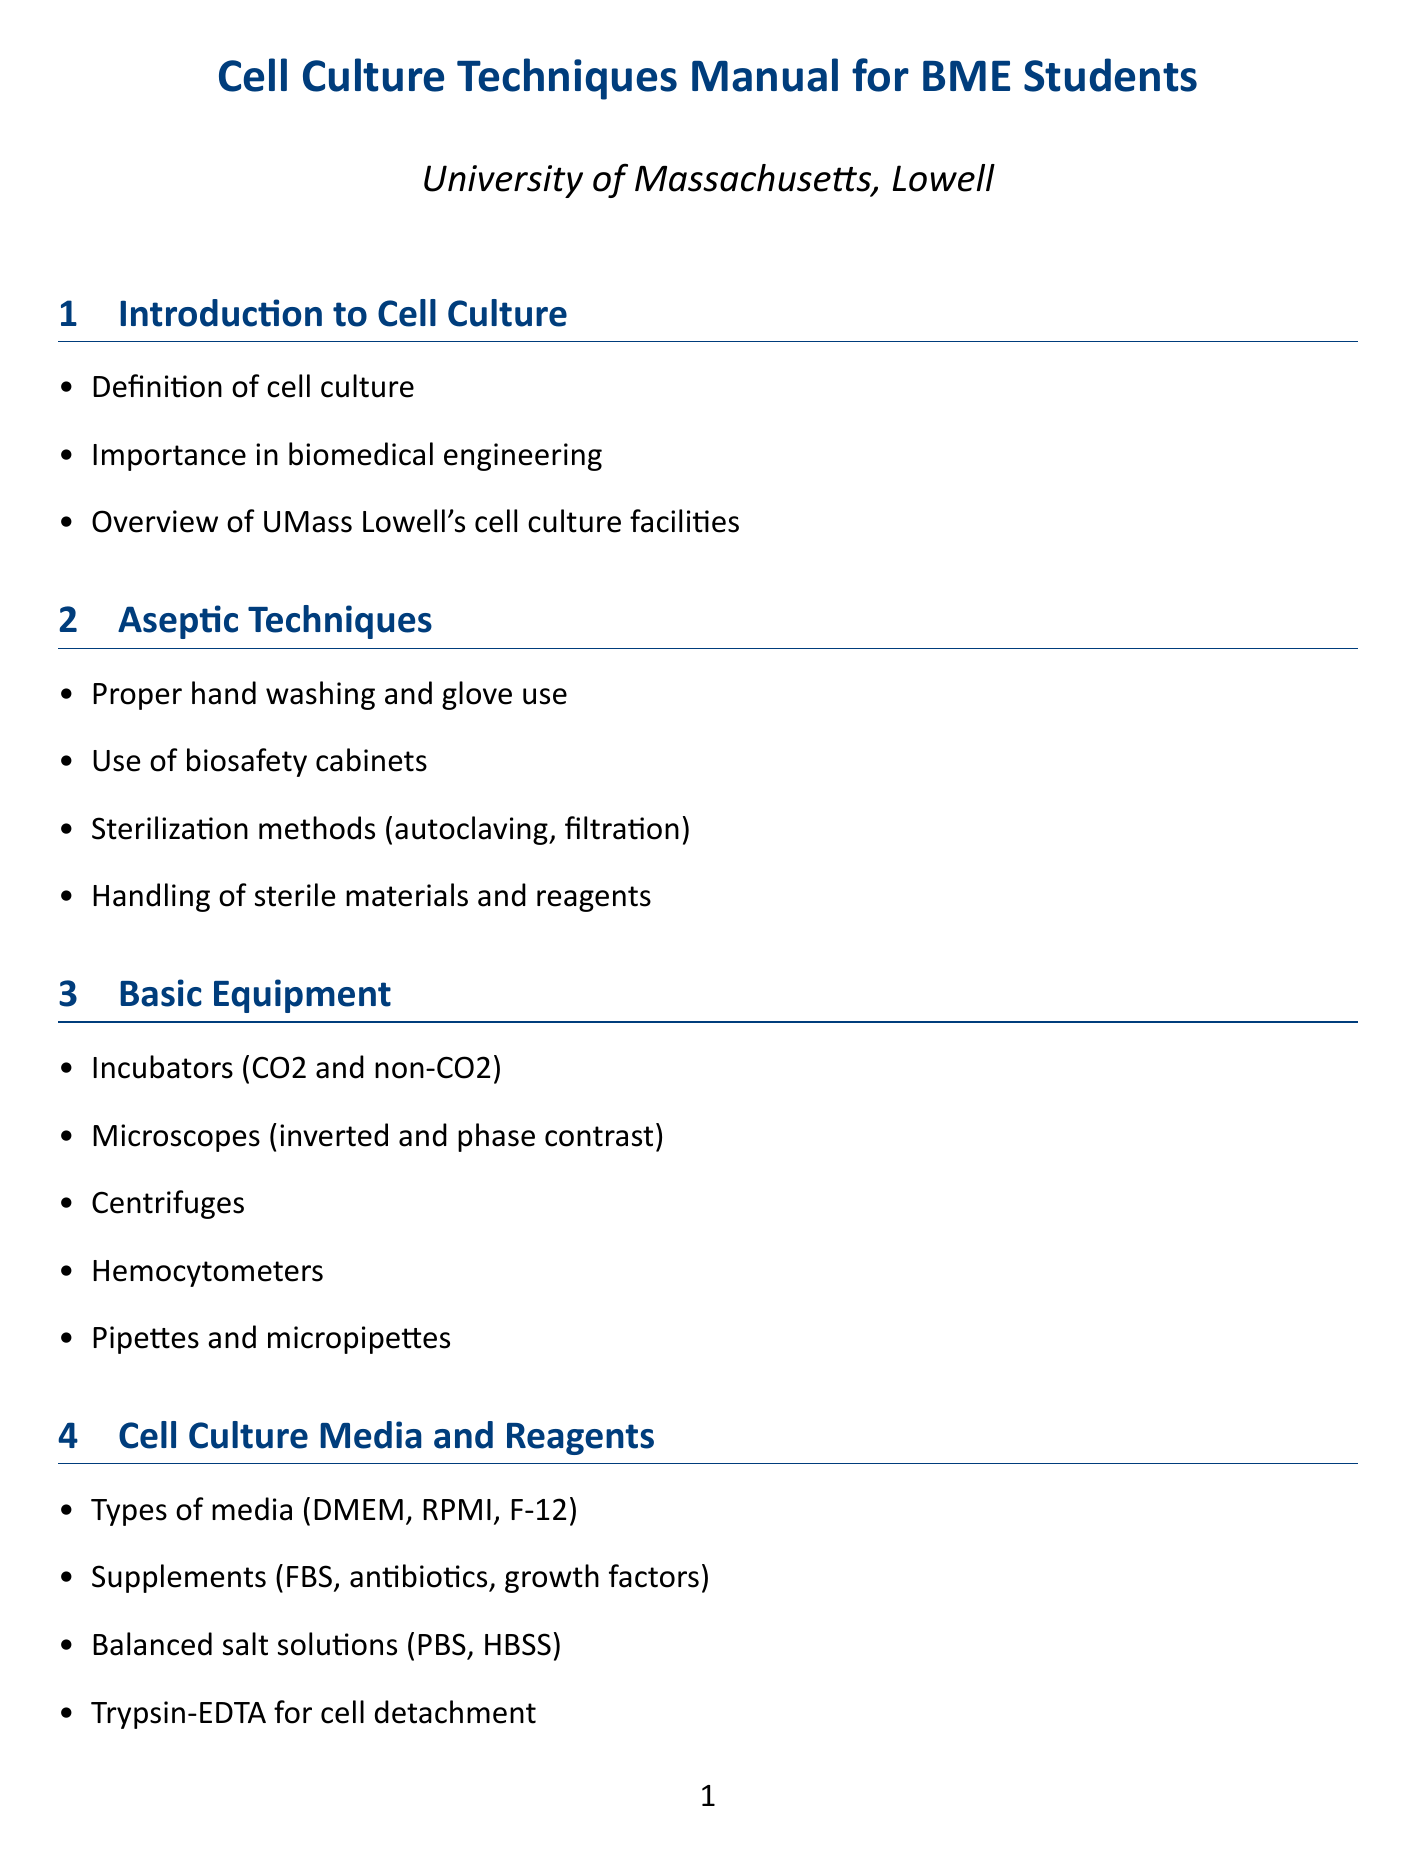what is the importance of cell culture in biomedical engineering? The importance of cell culture in biomedical engineering is discussed in the Introduction to Cell Culture section.
Answer: Importance in biomedical engineering what type of incubators are mentioned in the manual? Incubators mentioned in the Basic Equipment section include CO2 and non-CO2 incubators.
Answer: CO2 and non-CO2 what is the purpose of Trypsin-EDTA? The section on Cell Culture Media and Reagents indicates that Trypsin-EDTA is used for cell detachment.
Answer: Cell detachment how are cells prepared for freezing? The Cryopreservation section outlines the procedure for preparing cells for freezing.
Answer: Preparing cells for freezing what is the first step in the initiation of cell culture? The Initiation of Cell Culture section specifies that the first step is thawing frozen cells.
Answer: Thawing frozen cells what does STR stand for in cell line authentication? The Cell Line Authentication section refers to STR profiling.
Answer: Short Tandem Repeat what should be done in case of spills or exposures? The Safety Considerations section suggests following emergency procedures in case of spills or exposures.
Answer: Emergency procedures what is a common source of contamination in cell cultures? The Contamination Prevention and Detection section lists common sources of contamination.
Answer: Common sources of contamination how often should media changes occur? The Maintenance of Cell Lines section discusses media changes but doesn't specify frequency; it highlights the importance of feeding schedules.
Answer: Feeding schedules 